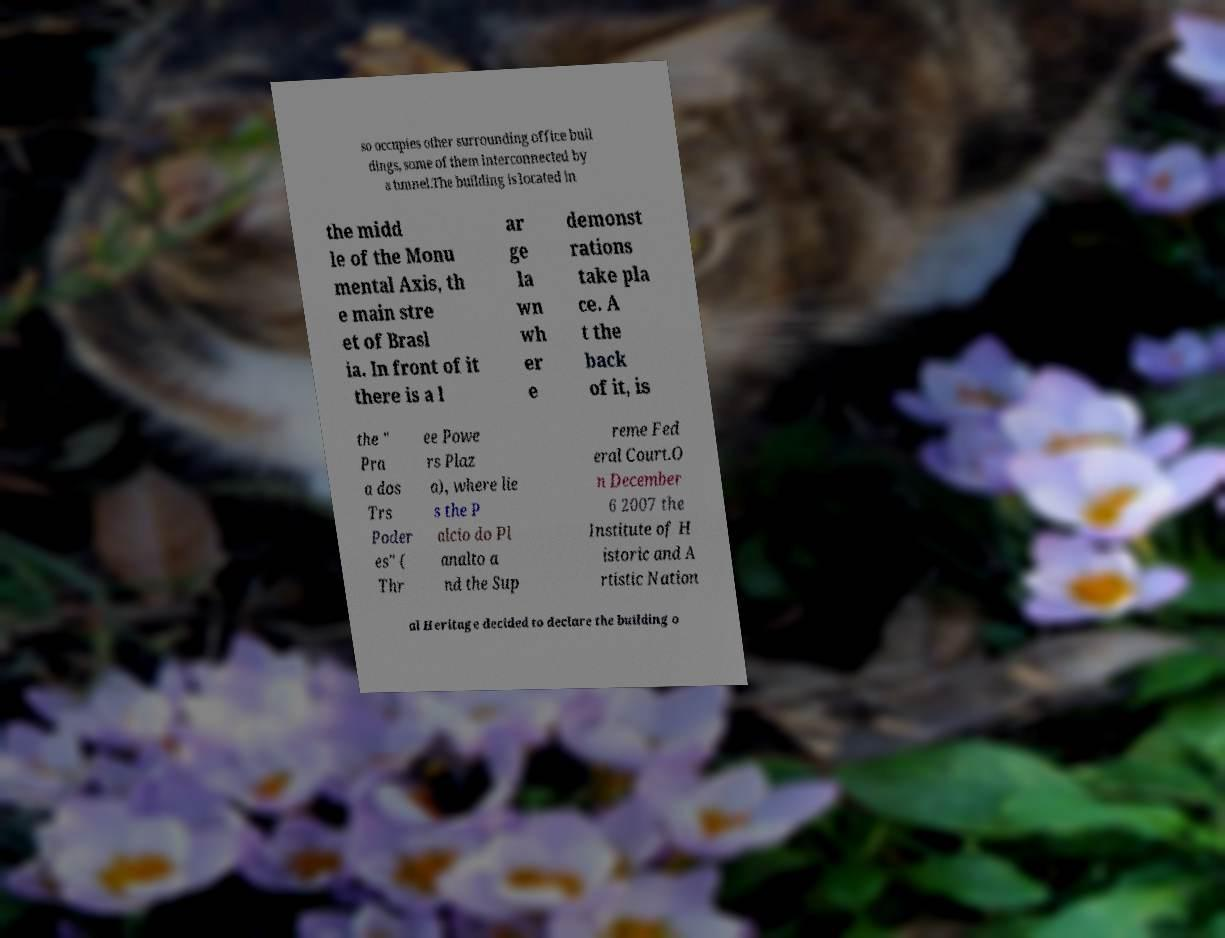Could you extract and type out the text from this image? so occupies other surrounding office buil dings, some of them interconnected by a tunnel.The building is located in the midd le of the Monu mental Axis, th e main stre et of Brasl ia. In front of it there is a l ar ge la wn wh er e demonst rations take pla ce. A t the back of it, is the " Pra a dos Trs Poder es" ( Thr ee Powe rs Plaz a), where lie s the P alcio do Pl analto a nd the Sup reme Fed eral Court.O n December 6 2007 the Institute of H istoric and A rtistic Nation al Heritage decided to declare the building o 